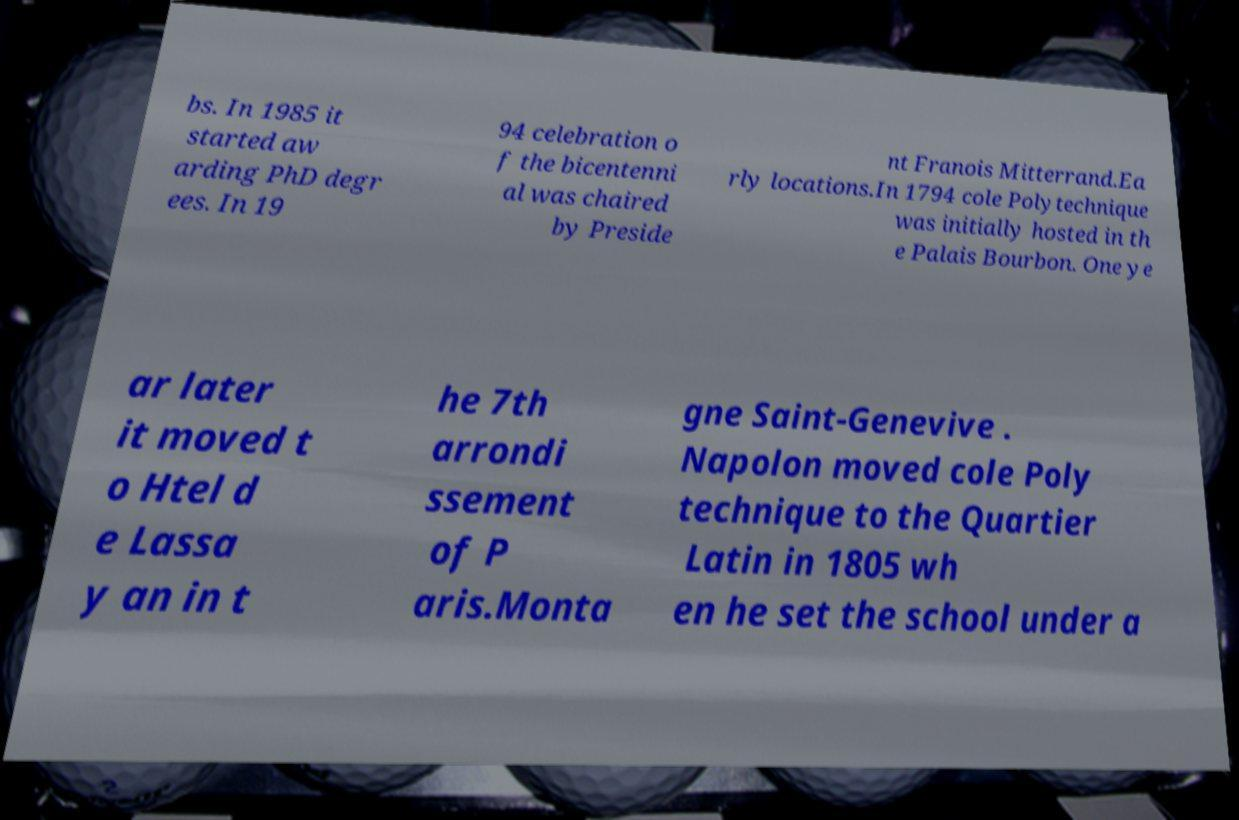Can you accurately transcribe the text from the provided image for me? bs. In 1985 it started aw arding PhD degr ees. In 19 94 celebration o f the bicentenni al was chaired by Preside nt Franois Mitterrand.Ea rly locations.In 1794 cole Polytechnique was initially hosted in th e Palais Bourbon. One ye ar later it moved t o Htel d e Lassa y an in t he 7th arrondi ssement of P aris.Monta gne Saint-Genevive . Napolon moved cole Poly technique to the Quartier Latin in 1805 wh en he set the school under a 